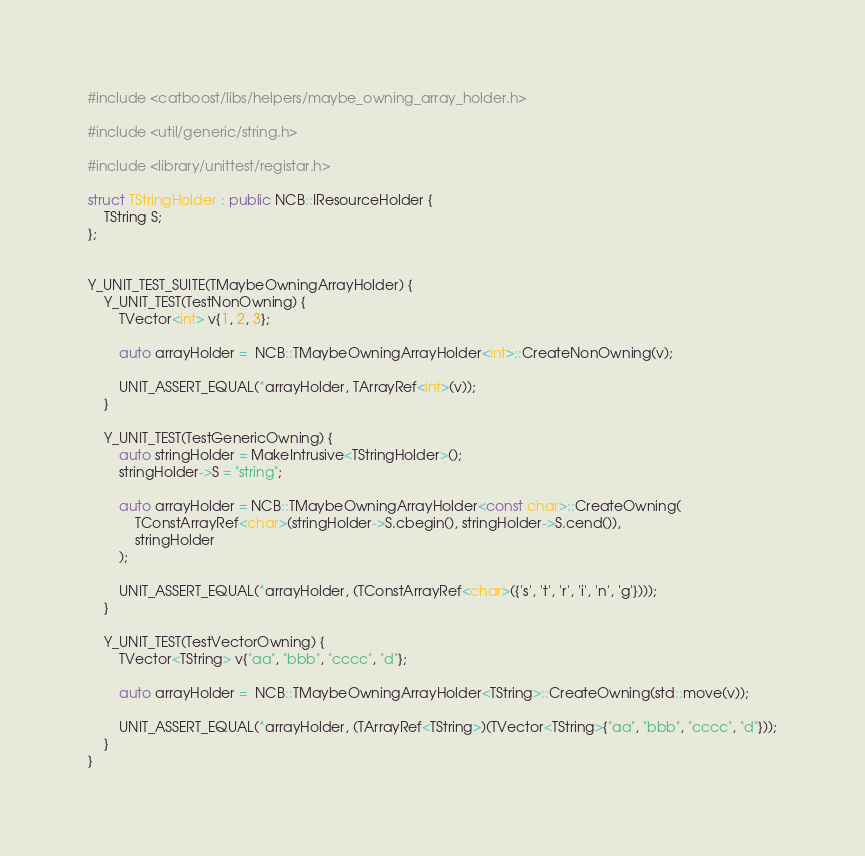Convert code to text. <code><loc_0><loc_0><loc_500><loc_500><_C++_>#include <catboost/libs/helpers/maybe_owning_array_holder.h>

#include <util/generic/string.h>

#include <library/unittest/registar.h>

struct TStringHolder : public NCB::IResourceHolder {
    TString S;
};


Y_UNIT_TEST_SUITE(TMaybeOwningArrayHolder) {
    Y_UNIT_TEST(TestNonOwning) {
        TVector<int> v{1, 2, 3};

        auto arrayHolder =  NCB::TMaybeOwningArrayHolder<int>::CreateNonOwning(v);

        UNIT_ASSERT_EQUAL(*arrayHolder, TArrayRef<int>(v));
    }

    Y_UNIT_TEST(TestGenericOwning) {
        auto stringHolder = MakeIntrusive<TStringHolder>();
        stringHolder->S = "string";

        auto arrayHolder = NCB::TMaybeOwningArrayHolder<const char>::CreateOwning(
            TConstArrayRef<char>(stringHolder->S.cbegin(), stringHolder->S.cend()),
            stringHolder
        );

        UNIT_ASSERT_EQUAL(*arrayHolder, (TConstArrayRef<char>({'s', 't', 'r', 'i', 'n', 'g'})));
    }

    Y_UNIT_TEST(TestVectorOwning) {
        TVector<TString> v{"aa", "bbb", "cccc", "d"};

        auto arrayHolder =  NCB::TMaybeOwningArrayHolder<TString>::CreateOwning(std::move(v));

        UNIT_ASSERT_EQUAL(*arrayHolder, (TArrayRef<TString>)(TVector<TString>{"aa", "bbb", "cccc", "d"}));
    }
}
</code> 